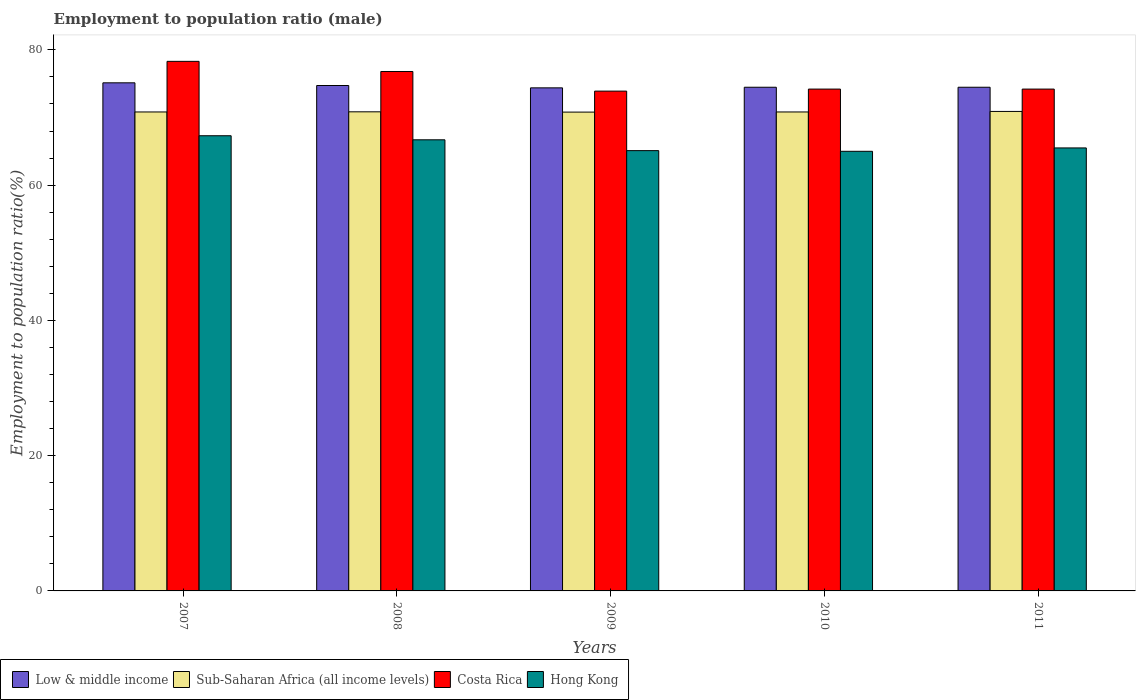How many different coloured bars are there?
Ensure brevity in your answer.  4. Are the number of bars per tick equal to the number of legend labels?
Make the answer very short. Yes. How many bars are there on the 3rd tick from the left?
Keep it short and to the point. 4. What is the label of the 2nd group of bars from the left?
Ensure brevity in your answer.  2008. What is the employment to population ratio in Costa Rica in 2008?
Offer a terse response. 76.8. Across all years, what is the maximum employment to population ratio in Sub-Saharan Africa (all income levels)?
Provide a succinct answer. 70.9. Across all years, what is the minimum employment to population ratio in Sub-Saharan Africa (all income levels)?
Offer a very short reply. 70.8. In which year was the employment to population ratio in Hong Kong maximum?
Offer a terse response. 2007. What is the total employment to population ratio in Low & middle income in the graph?
Offer a terse response. 373.18. What is the difference between the employment to population ratio in Hong Kong in 2007 and that in 2008?
Your answer should be very brief. 0.6. What is the difference between the employment to population ratio in Low & middle income in 2007 and the employment to population ratio in Hong Kong in 2011?
Give a very brief answer. 9.63. What is the average employment to population ratio in Low & middle income per year?
Keep it short and to the point. 74.64. In the year 2009, what is the difference between the employment to population ratio in Costa Rica and employment to population ratio in Sub-Saharan Africa (all income levels)?
Provide a succinct answer. 3.1. What is the ratio of the employment to population ratio in Sub-Saharan Africa (all income levels) in 2009 to that in 2011?
Your response must be concise. 1. What is the difference between the highest and the second highest employment to population ratio in Sub-Saharan Africa (all income levels)?
Offer a very short reply. 0.06. What is the difference between the highest and the lowest employment to population ratio in Hong Kong?
Provide a short and direct response. 2.3. Is it the case that in every year, the sum of the employment to population ratio in Low & middle income and employment to population ratio in Costa Rica is greater than the sum of employment to population ratio in Sub-Saharan Africa (all income levels) and employment to population ratio in Hong Kong?
Your response must be concise. Yes. What does the 3rd bar from the left in 2008 represents?
Give a very brief answer. Costa Rica. What does the 1st bar from the right in 2010 represents?
Give a very brief answer. Hong Kong. Is it the case that in every year, the sum of the employment to population ratio in Costa Rica and employment to population ratio in Low & middle income is greater than the employment to population ratio in Sub-Saharan Africa (all income levels)?
Your answer should be compact. Yes. Are all the bars in the graph horizontal?
Provide a short and direct response. No. Does the graph contain any zero values?
Give a very brief answer. No. Does the graph contain grids?
Your answer should be very brief. No. Where does the legend appear in the graph?
Keep it short and to the point. Bottom left. How are the legend labels stacked?
Keep it short and to the point. Horizontal. What is the title of the graph?
Ensure brevity in your answer.  Employment to population ratio (male). Does "Greenland" appear as one of the legend labels in the graph?
Your response must be concise. No. What is the label or title of the X-axis?
Your answer should be compact. Years. What is the Employment to population ratio(%) of Low & middle income in 2007?
Ensure brevity in your answer.  75.13. What is the Employment to population ratio(%) in Sub-Saharan Africa (all income levels) in 2007?
Your answer should be compact. 70.82. What is the Employment to population ratio(%) in Costa Rica in 2007?
Provide a short and direct response. 78.3. What is the Employment to population ratio(%) in Hong Kong in 2007?
Keep it short and to the point. 67.3. What is the Employment to population ratio(%) of Low & middle income in 2008?
Offer a very short reply. 74.73. What is the Employment to population ratio(%) in Sub-Saharan Africa (all income levels) in 2008?
Ensure brevity in your answer.  70.84. What is the Employment to population ratio(%) in Costa Rica in 2008?
Make the answer very short. 76.8. What is the Employment to population ratio(%) of Hong Kong in 2008?
Your response must be concise. 66.7. What is the Employment to population ratio(%) of Low & middle income in 2009?
Keep it short and to the point. 74.38. What is the Employment to population ratio(%) in Sub-Saharan Africa (all income levels) in 2009?
Make the answer very short. 70.8. What is the Employment to population ratio(%) of Costa Rica in 2009?
Your response must be concise. 73.9. What is the Employment to population ratio(%) in Hong Kong in 2009?
Provide a succinct answer. 65.1. What is the Employment to population ratio(%) of Low & middle income in 2010?
Provide a succinct answer. 74.47. What is the Employment to population ratio(%) of Sub-Saharan Africa (all income levels) in 2010?
Ensure brevity in your answer.  70.82. What is the Employment to population ratio(%) in Costa Rica in 2010?
Provide a short and direct response. 74.2. What is the Employment to population ratio(%) of Hong Kong in 2010?
Keep it short and to the point. 65. What is the Employment to population ratio(%) of Low & middle income in 2011?
Make the answer very short. 74.47. What is the Employment to population ratio(%) of Sub-Saharan Africa (all income levels) in 2011?
Provide a succinct answer. 70.9. What is the Employment to population ratio(%) of Costa Rica in 2011?
Ensure brevity in your answer.  74.2. What is the Employment to population ratio(%) in Hong Kong in 2011?
Ensure brevity in your answer.  65.5. Across all years, what is the maximum Employment to population ratio(%) of Low & middle income?
Ensure brevity in your answer.  75.13. Across all years, what is the maximum Employment to population ratio(%) of Sub-Saharan Africa (all income levels)?
Your answer should be very brief. 70.9. Across all years, what is the maximum Employment to population ratio(%) of Costa Rica?
Your answer should be very brief. 78.3. Across all years, what is the maximum Employment to population ratio(%) in Hong Kong?
Ensure brevity in your answer.  67.3. Across all years, what is the minimum Employment to population ratio(%) in Low & middle income?
Give a very brief answer. 74.38. Across all years, what is the minimum Employment to population ratio(%) of Sub-Saharan Africa (all income levels)?
Make the answer very short. 70.8. Across all years, what is the minimum Employment to population ratio(%) in Costa Rica?
Give a very brief answer. 73.9. What is the total Employment to population ratio(%) of Low & middle income in the graph?
Provide a succinct answer. 373.18. What is the total Employment to population ratio(%) in Sub-Saharan Africa (all income levels) in the graph?
Offer a terse response. 354.16. What is the total Employment to population ratio(%) in Costa Rica in the graph?
Your answer should be very brief. 377.4. What is the total Employment to population ratio(%) of Hong Kong in the graph?
Provide a succinct answer. 329.6. What is the difference between the Employment to population ratio(%) in Low & middle income in 2007 and that in 2008?
Your response must be concise. 0.4. What is the difference between the Employment to population ratio(%) in Sub-Saharan Africa (all income levels) in 2007 and that in 2008?
Provide a short and direct response. -0.02. What is the difference between the Employment to population ratio(%) of Costa Rica in 2007 and that in 2008?
Your answer should be compact. 1.5. What is the difference between the Employment to population ratio(%) in Low & middle income in 2007 and that in 2009?
Offer a terse response. 0.74. What is the difference between the Employment to population ratio(%) of Sub-Saharan Africa (all income levels) in 2007 and that in 2009?
Your answer should be compact. 0.02. What is the difference between the Employment to population ratio(%) of Low & middle income in 2007 and that in 2010?
Your response must be concise. 0.65. What is the difference between the Employment to population ratio(%) in Sub-Saharan Africa (all income levels) in 2007 and that in 2010?
Provide a succinct answer. -0. What is the difference between the Employment to population ratio(%) in Costa Rica in 2007 and that in 2010?
Ensure brevity in your answer.  4.1. What is the difference between the Employment to population ratio(%) of Hong Kong in 2007 and that in 2010?
Your answer should be compact. 2.3. What is the difference between the Employment to population ratio(%) in Low & middle income in 2007 and that in 2011?
Ensure brevity in your answer.  0.65. What is the difference between the Employment to population ratio(%) in Sub-Saharan Africa (all income levels) in 2007 and that in 2011?
Give a very brief answer. -0.08. What is the difference between the Employment to population ratio(%) in Low & middle income in 2008 and that in 2009?
Make the answer very short. 0.35. What is the difference between the Employment to population ratio(%) of Sub-Saharan Africa (all income levels) in 2008 and that in 2009?
Give a very brief answer. 0.04. What is the difference between the Employment to population ratio(%) in Hong Kong in 2008 and that in 2009?
Give a very brief answer. 1.6. What is the difference between the Employment to population ratio(%) of Low & middle income in 2008 and that in 2010?
Offer a very short reply. 0.26. What is the difference between the Employment to population ratio(%) in Sub-Saharan Africa (all income levels) in 2008 and that in 2010?
Make the answer very short. 0.02. What is the difference between the Employment to population ratio(%) of Hong Kong in 2008 and that in 2010?
Your response must be concise. 1.7. What is the difference between the Employment to population ratio(%) in Low & middle income in 2008 and that in 2011?
Your answer should be very brief. 0.26. What is the difference between the Employment to population ratio(%) in Sub-Saharan Africa (all income levels) in 2008 and that in 2011?
Ensure brevity in your answer.  -0.06. What is the difference between the Employment to population ratio(%) of Low & middle income in 2009 and that in 2010?
Offer a terse response. -0.09. What is the difference between the Employment to population ratio(%) of Sub-Saharan Africa (all income levels) in 2009 and that in 2010?
Provide a short and direct response. -0.02. What is the difference between the Employment to population ratio(%) of Low & middle income in 2009 and that in 2011?
Your answer should be very brief. -0.09. What is the difference between the Employment to population ratio(%) of Sub-Saharan Africa (all income levels) in 2009 and that in 2011?
Provide a short and direct response. -0.1. What is the difference between the Employment to population ratio(%) in Costa Rica in 2009 and that in 2011?
Your answer should be compact. -0.3. What is the difference between the Employment to population ratio(%) in Hong Kong in 2009 and that in 2011?
Offer a terse response. -0.4. What is the difference between the Employment to population ratio(%) of Low & middle income in 2010 and that in 2011?
Keep it short and to the point. 0. What is the difference between the Employment to population ratio(%) in Sub-Saharan Africa (all income levels) in 2010 and that in 2011?
Keep it short and to the point. -0.08. What is the difference between the Employment to population ratio(%) in Low & middle income in 2007 and the Employment to population ratio(%) in Sub-Saharan Africa (all income levels) in 2008?
Provide a short and direct response. 4.29. What is the difference between the Employment to population ratio(%) of Low & middle income in 2007 and the Employment to population ratio(%) of Costa Rica in 2008?
Make the answer very short. -1.67. What is the difference between the Employment to population ratio(%) of Low & middle income in 2007 and the Employment to population ratio(%) of Hong Kong in 2008?
Give a very brief answer. 8.43. What is the difference between the Employment to population ratio(%) in Sub-Saharan Africa (all income levels) in 2007 and the Employment to population ratio(%) in Costa Rica in 2008?
Provide a succinct answer. -5.98. What is the difference between the Employment to population ratio(%) in Sub-Saharan Africa (all income levels) in 2007 and the Employment to population ratio(%) in Hong Kong in 2008?
Give a very brief answer. 4.12. What is the difference between the Employment to population ratio(%) of Costa Rica in 2007 and the Employment to population ratio(%) of Hong Kong in 2008?
Keep it short and to the point. 11.6. What is the difference between the Employment to population ratio(%) in Low & middle income in 2007 and the Employment to population ratio(%) in Sub-Saharan Africa (all income levels) in 2009?
Give a very brief answer. 4.33. What is the difference between the Employment to population ratio(%) of Low & middle income in 2007 and the Employment to population ratio(%) of Costa Rica in 2009?
Offer a very short reply. 1.23. What is the difference between the Employment to population ratio(%) of Low & middle income in 2007 and the Employment to population ratio(%) of Hong Kong in 2009?
Ensure brevity in your answer.  10.03. What is the difference between the Employment to population ratio(%) of Sub-Saharan Africa (all income levels) in 2007 and the Employment to population ratio(%) of Costa Rica in 2009?
Provide a succinct answer. -3.08. What is the difference between the Employment to population ratio(%) of Sub-Saharan Africa (all income levels) in 2007 and the Employment to population ratio(%) of Hong Kong in 2009?
Your response must be concise. 5.72. What is the difference between the Employment to population ratio(%) in Low & middle income in 2007 and the Employment to population ratio(%) in Sub-Saharan Africa (all income levels) in 2010?
Offer a very short reply. 4.31. What is the difference between the Employment to population ratio(%) in Low & middle income in 2007 and the Employment to population ratio(%) in Costa Rica in 2010?
Your answer should be compact. 0.93. What is the difference between the Employment to population ratio(%) of Low & middle income in 2007 and the Employment to population ratio(%) of Hong Kong in 2010?
Your answer should be very brief. 10.13. What is the difference between the Employment to population ratio(%) of Sub-Saharan Africa (all income levels) in 2007 and the Employment to population ratio(%) of Costa Rica in 2010?
Offer a very short reply. -3.38. What is the difference between the Employment to population ratio(%) in Sub-Saharan Africa (all income levels) in 2007 and the Employment to population ratio(%) in Hong Kong in 2010?
Give a very brief answer. 5.82. What is the difference between the Employment to population ratio(%) of Costa Rica in 2007 and the Employment to population ratio(%) of Hong Kong in 2010?
Make the answer very short. 13.3. What is the difference between the Employment to population ratio(%) in Low & middle income in 2007 and the Employment to population ratio(%) in Sub-Saharan Africa (all income levels) in 2011?
Offer a very short reply. 4.23. What is the difference between the Employment to population ratio(%) in Low & middle income in 2007 and the Employment to population ratio(%) in Costa Rica in 2011?
Your answer should be very brief. 0.93. What is the difference between the Employment to population ratio(%) of Low & middle income in 2007 and the Employment to population ratio(%) of Hong Kong in 2011?
Provide a succinct answer. 9.63. What is the difference between the Employment to population ratio(%) in Sub-Saharan Africa (all income levels) in 2007 and the Employment to population ratio(%) in Costa Rica in 2011?
Provide a succinct answer. -3.38. What is the difference between the Employment to population ratio(%) in Sub-Saharan Africa (all income levels) in 2007 and the Employment to population ratio(%) in Hong Kong in 2011?
Your answer should be very brief. 5.32. What is the difference between the Employment to population ratio(%) in Costa Rica in 2007 and the Employment to population ratio(%) in Hong Kong in 2011?
Provide a short and direct response. 12.8. What is the difference between the Employment to population ratio(%) in Low & middle income in 2008 and the Employment to population ratio(%) in Sub-Saharan Africa (all income levels) in 2009?
Keep it short and to the point. 3.93. What is the difference between the Employment to population ratio(%) of Low & middle income in 2008 and the Employment to population ratio(%) of Costa Rica in 2009?
Offer a very short reply. 0.83. What is the difference between the Employment to population ratio(%) in Low & middle income in 2008 and the Employment to population ratio(%) in Hong Kong in 2009?
Keep it short and to the point. 9.63. What is the difference between the Employment to population ratio(%) in Sub-Saharan Africa (all income levels) in 2008 and the Employment to population ratio(%) in Costa Rica in 2009?
Your answer should be compact. -3.06. What is the difference between the Employment to population ratio(%) of Sub-Saharan Africa (all income levels) in 2008 and the Employment to population ratio(%) of Hong Kong in 2009?
Provide a succinct answer. 5.74. What is the difference between the Employment to population ratio(%) in Low & middle income in 2008 and the Employment to population ratio(%) in Sub-Saharan Africa (all income levels) in 2010?
Your response must be concise. 3.91. What is the difference between the Employment to population ratio(%) of Low & middle income in 2008 and the Employment to population ratio(%) of Costa Rica in 2010?
Keep it short and to the point. 0.53. What is the difference between the Employment to population ratio(%) in Low & middle income in 2008 and the Employment to population ratio(%) in Hong Kong in 2010?
Make the answer very short. 9.73. What is the difference between the Employment to population ratio(%) of Sub-Saharan Africa (all income levels) in 2008 and the Employment to population ratio(%) of Costa Rica in 2010?
Your response must be concise. -3.36. What is the difference between the Employment to population ratio(%) in Sub-Saharan Africa (all income levels) in 2008 and the Employment to population ratio(%) in Hong Kong in 2010?
Your answer should be very brief. 5.84. What is the difference between the Employment to population ratio(%) in Low & middle income in 2008 and the Employment to population ratio(%) in Sub-Saharan Africa (all income levels) in 2011?
Ensure brevity in your answer.  3.83. What is the difference between the Employment to population ratio(%) in Low & middle income in 2008 and the Employment to population ratio(%) in Costa Rica in 2011?
Keep it short and to the point. 0.53. What is the difference between the Employment to population ratio(%) of Low & middle income in 2008 and the Employment to population ratio(%) of Hong Kong in 2011?
Your answer should be compact. 9.23. What is the difference between the Employment to population ratio(%) in Sub-Saharan Africa (all income levels) in 2008 and the Employment to population ratio(%) in Costa Rica in 2011?
Make the answer very short. -3.36. What is the difference between the Employment to population ratio(%) of Sub-Saharan Africa (all income levels) in 2008 and the Employment to population ratio(%) of Hong Kong in 2011?
Your answer should be compact. 5.34. What is the difference between the Employment to population ratio(%) of Low & middle income in 2009 and the Employment to population ratio(%) of Sub-Saharan Africa (all income levels) in 2010?
Offer a terse response. 3.56. What is the difference between the Employment to population ratio(%) in Low & middle income in 2009 and the Employment to population ratio(%) in Costa Rica in 2010?
Ensure brevity in your answer.  0.18. What is the difference between the Employment to population ratio(%) in Low & middle income in 2009 and the Employment to population ratio(%) in Hong Kong in 2010?
Provide a short and direct response. 9.38. What is the difference between the Employment to population ratio(%) of Sub-Saharan Africa (all income levels) in 2009 and the Employment to population ratio(%) of Costa Rica in 2010?
Your answer should be very brief. -3.4. What is the difference between the Employment to population ratio(%) in Sub-Saharan Africa (all income levels) in 2009 and the Employment to population ratio(%) in Hong Kong in 2010?
Your answer should be compact. 5.8. What is the difference between the Employment to population ratio(%) of Costa Rica in 2009 and the Employment to population ratio(%) of Hong Kong in 2010?
Provide a short and direct response. 8.9. What is the difference between the Employment to population ratio(%) of Low & middle income in 2009 and the Employment to population ratio(%) of Sub-Saharan Africa (all income levels) in 2011?
Your answer should be compact. 3.49. What is the difference between the Employment to population ratio(%) of Low & middle income in 2009 and the Employment to population ratio(%) of Costa Rica in 2011?
Provide a succinct answer. 0.18. What is the difference between the Employment to population ratio(%) of Low & middle income in 2009 and the Employment to population ratio(%) of Hong Kong in 2011?
Give a very brief answer. 8.88. What is the difference between the Employment to population ratio(%) of Sub-Saharan Africa (all income levels) in 2009 and the Employment to population ratio(%) of Costa Rica in 2011?
Offer a very short reply. -3.4. What is the difference between the Employment to population ratio(%) of Sub-Saharan Africa (all income levels) in 2009 and the Employment to population ratio(%) of Hong Kong in 2011?
Give a very brief answer. 5.3. What is the difference between the Employment to population ratio(%) of Costa Rica in 2009 and the Employment to population ratio(%) of Hong Kong in 2011?
Offer a very short reply. 8.4. What is the difference between the Employment to population ratio(%) in Low & middle income in 2010 and the Employment to population ratio(%) in Sub-Saharan Africa (all income levels) in 2011?
Make the answer very short. 3.58. What is the difference between the Employment to population ratio(%) of Low & middle income in 2010 and the Employment to population ratio(%) of Costa Rica in 2011?
Provide a succinct answer. 0.27. What is the difference between the Employment to population ratio(%) in Low & middle income in 2010 and the Employment to population ratio(%) in Hong Kong in 2011?
Offer a very short reply. 8.97. What is the difference between the Employment to population ratio(%) in Sub-Saharan Africa (all income levels) in 2010 and the Employment to population ratio(%) in Costa Rica in 2011?
Offer a very short reply. -3.38. What is the difference between the Employment to population ratio(%) of Sub-Saharan Africa (all income levels) in 2010 and the Employment to population ratio(%) of Hong Kong in 2011?
Make the answer very short. 5.32. What is the average Employment to population ratio(%) in Low & middle income per year?
Give a very brief answer. 74.64. What is the average Employment to population ratio(%) in Sub-Saharan Africa (all income levels) per year?
Provide a short and direct response. 70.83. What is the average Employment to population ratio(%) in Costa Rica per year?
Keep it short and to the point. 75.48. What is the average Employment to population ratio(%) in Hong Kong per year?
Ensure brevity in your answer.  65.92. In the year 2007, what is the difference between the Employment to population ratio(%) of Low & middle income and Employment to population ratio(%) of Sub-Saharan Africa (all income levels)?
Ensure brevity in your answer.  4.31. In the year 2007, what is the difference between the Employment to population ratio(%) of Low & middle income and Employment to population ratio(%) of Costa Rica?
Your answer should be very brief. -3.17. In the year 2007, what is the difference between the Employment to population ratio(%) of Low & middle income and Employment to population ratio(%) of Hong Kong?
Offer a very short reply. 7.83. In the year 2007, what is the difference between the Employment to population ratio(%) in Sub-Saharan Africa (all income levels) and Employment to population ratio(%) in Costa Rica?
Give a very brief answer. -7.48. In the year 2007, what is the difference between the Employment to population ratio(%) in Sub-Saharan Africa (all income levels) and Employment to population ratio(%) in Hong Kong?
Your answer should be very brief. 3.52. In the year 2008, what is the difference between the Employment to population ratio(%) in Low & middle income and Employment to population ratio(%) in Sub-Saharan Africa (all income levels)?
Give a very brief answer. 3.89. In the year 2008, what is the difference between the Employment to population ratio(%) of Low & middle income and Employment to population ratio(%) of Costa Rica?
Give a very brief answer. -2.07. In the year 2008, what is the difference between the Employment to population ratio(%) in Low & middle income and Employment to population ratio(%) in Hong Kong?
Provide a short and direct response. 8.03. In the year 2008, what is the difference between the Employment to population ratio(%) of Sub-Saharan Africa (all income levels) and Employment to population ratio(%) of Costa Rica?
Provide a succinct answer. -5.96. In the year 2008, what is the difference between the Employment to population ratio(%) of Sub-Saharan Africa (all income levels) and Employment to population ratio(%) of Hong Kong?
Provide a short and direct response. 4.14. In the year 2008, what is the difference between the Employment to population ratio(%) of Costa Rica and Employment to population ratio(%) of Hong Kong?
Your response must be concise. 10.1. In the year 2009, what is the difference between the Employment to population ratio(%) in Low & middle income and Employment to population ratio(%) in Sub-Saharan Africa (all income levels)?
Your answer should be compact. 3.58. In the year 2009, what is the difference between the Employment to population ratio(%) in Low & middle income and Employment to population ratio(%) in Costa Rica?
Provide a succinct answer. 0.48. In the year 2009, what is the difference between the Employment to population ratio(%) of Low & middle income and Employment to population ratio(%) of Hong Kong?
Provide a succinct answer. 9.28. In the year 2009, what is the difference between the Employment to population ratio(%) in Sub-Saharan Africa (all income levels) and Employment to population ratio(%) in Costa Rica?
Your answer should be very brief. -3.1. In the year 2009, what is the difference between the Employment to population ratio(%) in Sub-Saharan Africa (all income levels) and Employment to population ratio(%) in Hong Kong?
Offer a very short reply. 5.7. In the year 2010, what is the difference between the Employment to population ratio(%) of Low & middle income and Employment to population ratio(%) of Sub-Saharan Africa (all income levels)?
Provide a succinct answer. 3.65. In the year 2010, what is the difference between the Employment to population ratio(%) of Low & middle income and Employment to population ratio(%) of Costa Rica?
Ensure brevity in your answer.  0.27. In the year 2010, what is the difference between the Employment to population ratio(%) in Low & middle income and Employment to population ratio(%) in Hong Kong?
Your answer should be compact. 9.47. In the year 2010, what is the difference between the Employment to population ratio(%) of Sub-Saharan Africa (all income levels) and Employment to population ratio(%) of Costa Rica?
Your answer should be compact. -3.38. In the year 2010, what is the difference between the Employment to population ratio(%) of Sub-Saharan Africa (all income levels) and Employment to population ratio(%) of Hong Kong?
Provide a succinct answer. 5.82. In the year 2011, what is the difference between the Employment to population ratio(%) of Low & middle income and Employment to population ratio(%) of Sub-Saharan Africa (all income levels)?
Your response must be concise. 3.58. In the year 2011, what is the difference between the Employment to population ratio(%) in Low & middle income and Employment to population ratio(%) in Costa Rica?
Keep it short and to the point. 0.27. In the year 2011, what is the difference between the Employment to population ratio(%) of Low & middle income and Employment to population ratio(%) of Hong Kong?
Provide a short and direct response. 8.97. In the year 2011, what is the difference between the Employment to population ratio(%) in Sub-Saharan Africa (all income levels) and Employment to population ratio(%) in Costa Rica?
Your answer should be compact. -3.3. In the year 2011, what is the difference between the Employment to population ratio(%) of Sub-Saharan Africa (all income levels) and Employment to population ratio(%) of Hong Kong?
Ensure brevity in your answer.  5.4. In the year 2011, what is the difference between the Employment to population ratio(%) of Costa Rica and Employment to population ratio(%) of Hong Kong?
Your response must be concise. 8.7. What is the ratio of the Employment to population ratio(%) of Costa Rica in 2007 to that in 2008?
Keep it short and to the point. 1.02. What is the ratio of the Employment to population ratio(%) of Hong Kong in 2007 to that in 2008?
Ensure brevity in your answer.  1.01. What is the ratio of the Employment to population ratio(%) in Low & middle income in 2007 to that in 2009?
Your answer should be very brief. 1.01. What is the ratio of the Employment to population ratio(%) in Sub-Saharan Africa (all income levels) in 2007 to that in 2009?
Provide a short and direct response. 1. What is the ratio of the Employment to population ratio(%) in Costa Rica in 2007 to that in 2009?
Provide a succinct answer. 1.06. What is the ratio of the Employment to population ratio(%) of Hong Kong in 2007 to that in 2009?
Make the answer very short. 1.03. What is the ratio of the Employment to population ratio(%) in Low & middle income in 2007 to that in 2010?
Give a very brief answer. 1.01. What is the ratio of the Employment to population ratio(%) of Sub-Saharan Africa (all income levels) in 2007 to that in 2010?
Give a very brief answer. 1. What is the ratio of the Employment to population ratio(%) of Costa Rica in 2007 to that in 2010?
Offer a terse response. 1.06. What is the ratio of the Employment to population ratio(%) of Hong Kong in 2007 to that in 2010?
Make the answer very short. 1.04. What is the ratio of the Employment to population ratio(%) of Low & middle income in 2007 to that in 2011?
Provide a short and direct response. 1.01. What is the ratio of the Employment to population ratio(%) in Costa Rica in 2007 to that in 2011?
Provide a succinct answer. 1.06. What is the ratio of the Employment to population ratio(%) of Hong Kong in 2007 to that in 2011?
Provide a succinct answer. 1.03. What is the ratio of the Employment to population ratio(%) of Costa Rica in 2008 to that in 2009?
Give a very brief answer. 1.04. What is the ratio of the Employment to population ratio(%) of Hong Kong in 2008 to that in 2009?
Provide a short and direct response. 1.02. What is the ratio of the Employment to population ratio(%) of Low & middle income in 2008 to that in 2010?
Keep it short and to the point. 1. What is the ratio of the Employment to population ratio(%) of Sub-Saharan Africa (all income levels) in 2008 to that in 2010?
Keep it short and to the point. 1. What is the ratio of the Employment to population ratio(%) of Costa Rica in 2008 to that in 2010?
Your answer should be compact. 1.03. What is the ratio of the Employment to population ratio(%) in Hong Kong in 2008 to that in 2010?
Provide a succinct answer. 1.03. What is the ratio of the Employment to population ratio(%) of Low & middle income in 2008 to that in 2011?
Offer a terse response. 1. What is the ratio of the Employment to population ratio(%) in Costa Rica in 2008 to that in 2011?
Keep it short and to the point. 1.03. What is the ratio of the Employment to population ratio(%) in Hong Kong in 2008 to that in 2011?
Give a very brief answer. 1.02. What is the ratio of the Employment to population ratio(%) in Low & middle income in 2009 to that in 2010?
Give a very brief answer. 1. What is the ratio of the Employment to population ratio(%) in Costa Rica in 2009 to that in 2010?
Your response must be concise. 1. What is the ratio of the Employment to population ratio(%) in Low & middle income in 2009 to that in 2011?
Your response must be concise. 1. What is the ratio of the Employment to population ratio(%) of Sub-Saharan Africa (all income levels) in 2009 to that in 2011?
Provide a succinct answer. 1. What is the ratio of the Employment to population ratio(%) in Hong Kong in 2009 to that in 2011?
Your answer should be very brief. 0.99. What is the ratio of the Employment to population ratio(%) of Low & middle income in 2010 to that in 2011?
Make the answer very short. 1. What is the difference between the highest and the second highest Employment to population ratio(%) in Low & middle income?
Offer a very short reply. 0.4. What is the difference between the highest and the second highest Employment to population ratio(%) in Sub-Saharan Africa (all income levels)?
Your answer should be compact. 0.06. What is the difference between the highest and the second highest Employment to population ratio(%) in Costa Rica?
Your answer should be very brief. 1.5. What is the difference between the highest and the second highest Employment to population ratio(%) of Hong Kong?
Offer a very short reply. 0.6. What is the difference between the highest and the lowest Employment to population ratio(%) of Low & middle income?
Give a very brief answer. 0.74. What is the difference between the highest and the lowest Employment to population ratio(%) in Sub-Saharan Africa (all income levels)?
Provide a short and direct response. 0.1. 